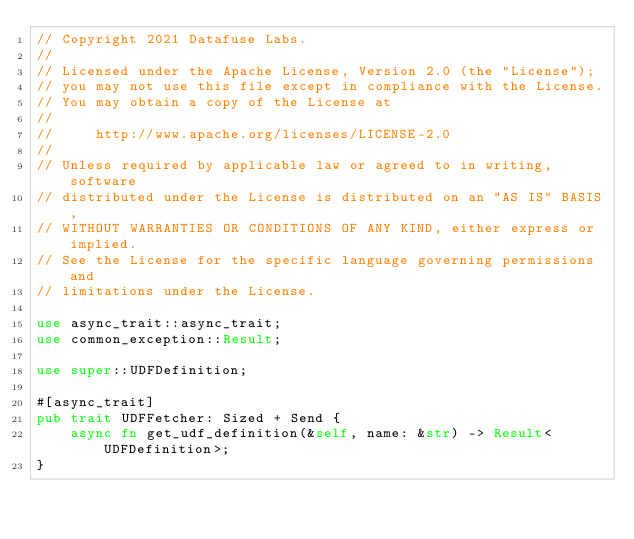Convert code to text. <code><loc_0><loc_0><loc_500><loc_500><_Rust_>// Copyright 2021 Datafuse Labs.
//
// Licensed under the Apache License, Version 2.0 (the "License");
// you may not use this file except in compliance with the License.
// You may obtain a copy of the License at
//
//     http://www.apache.org/licenses/LICENSE-2.0
//
// Unless required by applicable law or agreed to in writing, software
// distributed under the License is distributed on an "AS IS" BASIS,
// WITHOUT WARRANTIES OR CONDITIONS OF ANY KIND, either express or implied.
// See the License for the specific language governing permissions and
// limitations under the License.

use async_trait::async_trait;
use common_exception::Result;

use super::UDFDefinition;

#[async_trait]
pub trait UDFFetcher: Sized + Send {
    async fn get_udf_definition(&self, name: &str) -> Result<UDFDefinition>;
}
</code> 